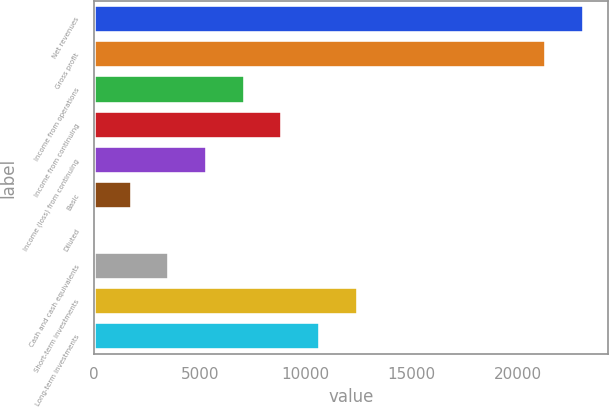<chart> <loc_0><loc_0><loc_500><loc_500><bar_chart><fcel>Net revenues<fcel>Gross profit<fcel>Income from operations<fcel>Income from continuing<fcel>Income (loss) from continuing<fcel>Basic<fcel>Diluted<fcel>Cash and cash equivalents<fcel>Short-term investments<fcel>Long-term investments<nl><fcel>23120<fcel>21341.7<fcel>7114.96<fcel>8893.3<fcel>5336.62<fcel>1779.94<fcel>1.6<fcel>3558.28<fcel>12450<fcel>10671.6<nl></chart> 